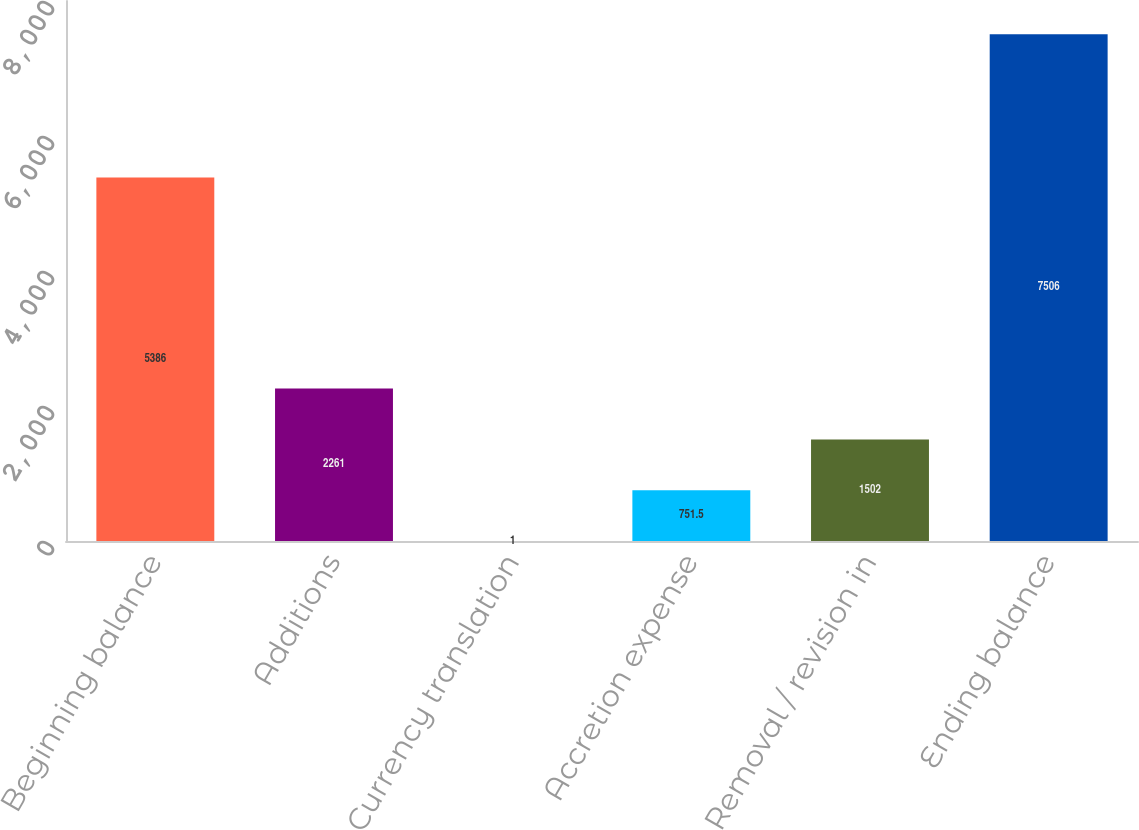Convert chart. <chart><loc_0><loc_0><loc_500><loc_500><bar_chart><fcel>Beginning balance<fcel>Additions<fcel>Currency translation<fcel>Accretion expense<fcel>Removal / revision in<fcel>Ending balance<nl><fcel>5386<fcel>2261<fcel>1<fcel>751.5<fcel>1502<fcel>7506<nl></chart> 